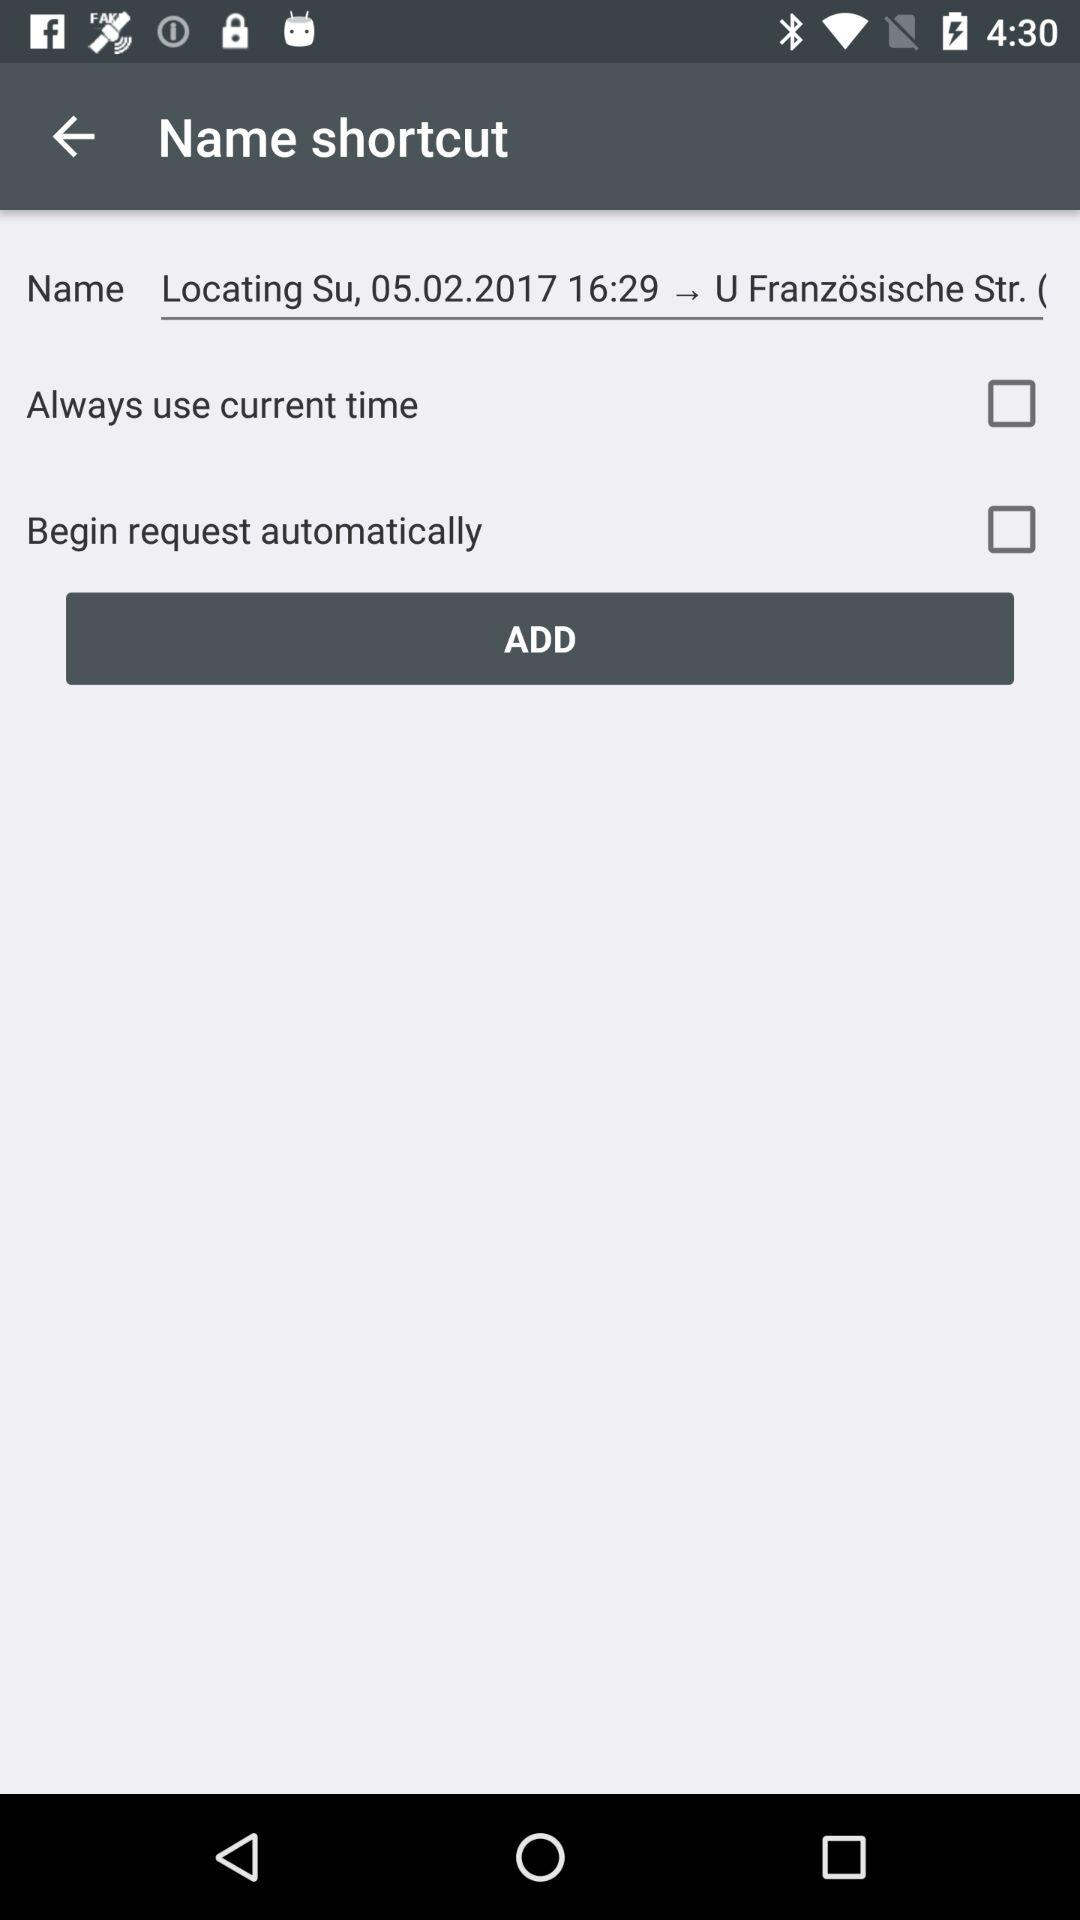How many checkboxes are enabled?
Answer the question using a single word or phrase. 2 